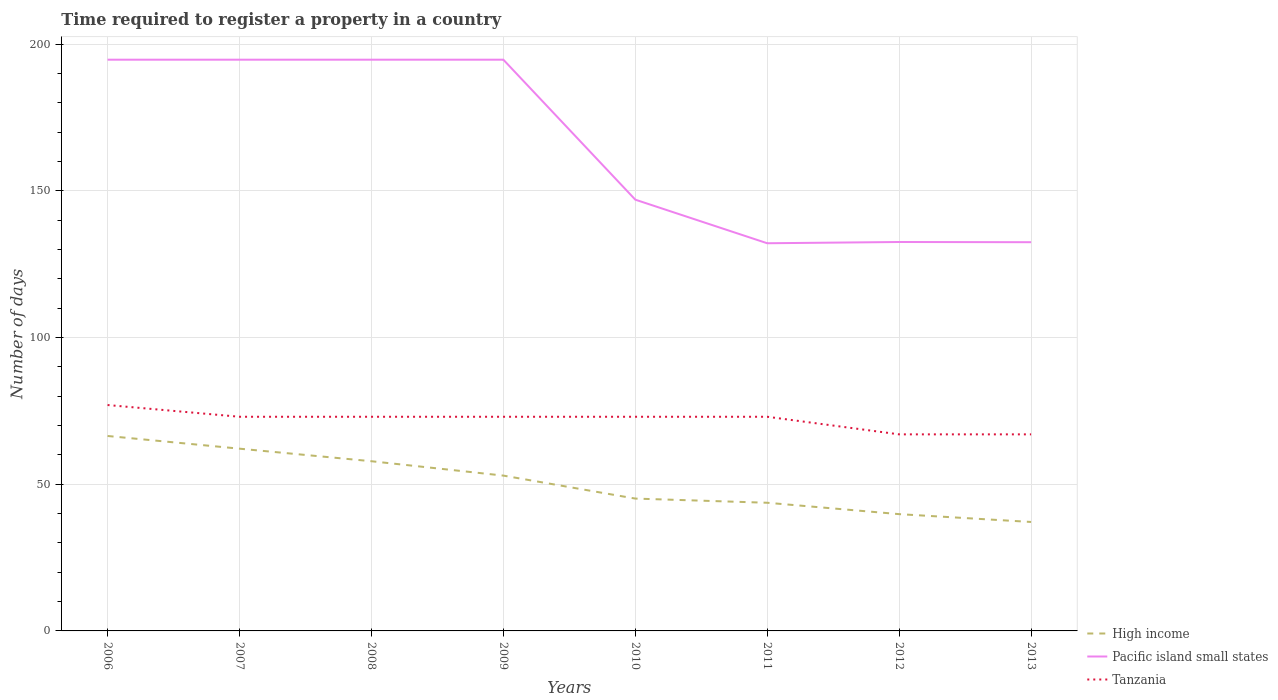How many different coloured lines are there?
Keep it short and to the point. 3. Does the line corresponding to Tanzania intersect with the line corresponding to Pacific island small states?
Your response must be concise. No. Is the number of lines equal to the number of legend labels?
Provide a short and direct response. Yes. Across all years, what is the maximum number of days required to register a property in Tanzania?
Offer a very short reply. 67. In which year was the number of days required to register a property in Pacific island small states maximum?
Give a very brief answer. 2011. What is the total number of days required to register a property in Tanzania in the graph?
Offer a terse response. 4. What is the difference between the highest and the second highest number of days required to register a property in Pacific island small states?
Provide a succinct answer. 62.57. Is the number of days required to register a property in Pacific island small states strictly greater than the number of days required to register a property in Tanzania over the years?
Provide a short and direct response. No. How many years are there in the graph?
Ensure brevity in your answer.  8. Are the values on the major ticks of Y-axis written in scientific E-notation?
Keep it short and to the point. No. Where does the legend appear in the graph?
Ensure brevity in your answer.  Bottom right. What is the title of the graph?
Your response must be concise. Time required to register a property in a country. Does "Antigua and Barbuda" appear as one of the legend labels in the graph?
Keep it short and to the point. No. What is the label or title of the X-axis?
Offer a terse response. Years. What is the label or title of the Y-axis?
Provide a succinct answer. Number of days. What is the Number of days in High income in 2006?
Your answer should be compact. 66.45. What is the Number of days of Pacific island small states in 2006?
Provide a succinct answer. 194.71. What is the Number of days in High income in 2007?
Offer a terse response. 62.12. What is the Number of days in Pacific island small states in 2007?
Your response must be concise. 194.71. What is the Number of days in High income in 2008?
Your response must be concise. 57.84. What is the Number of days in Pacific island small states in 2008?
Give a very brief answer. 194.71. What is the Number of days of Tanzania in 2008?
Make the answer very short. 73. What is the Number of days in High income in 2009?
Provide a succinct answer. 52.94. What is the Number of days of Pacific island small states in 2009?
Offer a terse response. 194.71. What is the Number of days in Tanzania in 2009?
Your answer should be very brief. 73. What is the Number of days of High income in 2010?
Your response must be concise. 45.11. What is the Number of days of Pacific island small states in 2010?
Make the answer very short. 147. What is the Number of days of Tanzania in 2010?
Provide a short and direct response. 73. What is the Number of days of High income in 2011?
Keep it short and to the point. 43.69. What is the Number of days in Pacific island small states in 2011?
Keep it short and to the point. 132.14. What is the Number of days of Tanzania in 2011?
Keep it short and to the point. 73. What is the Number of days in High income in 2012?
Your answer should be compact. 39.81. What is the Number of days in Pacific island small states in 2012?
Offer a terse response. 132.57. What is the Number of days in High income in 2013?
Your answer should be very brief. 37.14. What is the Number of days in Pacific island small states in 2013?
Give a very brief answer. 132.5. Across all years, what is the maximum Number of days of High income?
Provide a succinct answer. 66.45. Across all years, what is the maximum Number of days in Pacific island small states?
Provide a succinct answer. 194.71. Across all years, what is the minimum Number of days of High income?
Your response must be concise. 37.14. Across all years, what is the minimum Number of days of Pacific island small states?
Provide a succinct answer. 132.14. What is the total Number of days in High income in the graph?
Offer a terse response. 405.1. What is the total Number of days in Pacific island small states in the graph?
Ensure brevity in your answer.  1323.07. What is the total Number of days in Tanzania in the graph?
Your answer should be very brief. 576. What is the difference between the Number of days in High income in 2006 and that in 2007?
Provide a short and direct response. 4.33. What is the difference between the Number of days in Pacific island small states in 2006 and that in 2007?
Give a very brief answer. 0. What is the difference between the Number of days of High income in 2006 and that in 2008?
Your answer should be very brief. 8.61. What is the difference between the Number of days of Tanzania in 2006 and that in 2008?
Your answer should be compact. 4. What is the difference between the Number of days in High income in 2006 and that in 2009?
Ensure brevity in your answer.  13.51. What is the difference between the Number of days of Pacific island small states in 2006 and that in 2009?
Provide a short and direct response. 0. What is the difference between the Number of days of High income in 2006 and that in 2010?
Provide a short and direct response. 21.34. What is the difference between the Number of days in Pacific island small states in 2006 and that in 2010?
Offer a very short reply. 47.71. What is the difference between the Number of days in High income in 2006 and that in 2011?
Offer a very short reply. 22.76. What is the difference between the Number of days of Pacific island small states in 2006 and that in 2011?
Offer a very short reply. 62.57. What is the difference between the Number of days of High income in 2006 and that in 2012?
Keep it short and to the point. 26.64. What is the difference between the Number of days in Pacific island small states in 2006 and that in 2012?
Your answer should be very brief. 62.14. What is the difference between the Number of days in High income in 2006 and that in 2013?
Ensure brevity in your answer.  29.31. What is the difference between the Number of days of Pacific island small states in 2006 and that in 2013?
Offer a terse response. 62.21. What is the difference between the Number of days of Tanzania in 2006 and that in 2013?
Offer a very short reply. 10. What is the difference between the Number of days of High income in 2007 and that in 2008?
Your response must be concise. 4.28. What is the difference between the Number of days in Tanzania in 2007 and that in 2008?
Your answer should be very brief. 0. What is the difference between the Number of days in High income in 2007 and that in 2009?
Offer a very short reply. 9.18. What is the difference between the Number of days of Pacific island small states in 2007 and that in 2009?
Make the answer very short. 0. What is the difference between the Number of days of High income in 2007 and that in 2010?
Keep it short and to the point. 17.01. What is the difference between the Number of days of Pacific island small states in 2007 and that in 2010?
Offer a terse response. 47.71. What is the difference between the Number of days in High income in 2007 and that in 2011?
Your answer should be compact. 18.44. What is the difference between the Number of days in Pacific island small states in 2007 and that in 2011?
Provide a short and direct response. 62.57. What is the difference between the Number of days in High income in 2007 and that in 2012?
Your answer should be compact. 22.32. What is the difference between the Number of days in Pacific island small states in 2007 and that in 2012?
Provide a succinct answer. 62.14. What is the difference between the Number of days in High income in 2007 and that in 2013?
Keep it short and to the point. 24.99. What is the difference between the Number of days in Pacific island small states in 2007 and that in 2013?
Provide a succinct answer. 62.21. What is the difference between the Number of days in Tanzania in 2007 and that in 2013?
Give a very brief answer. 6. What is the difference between the Number of days of High income in 2008 and that in 2009?
Ensure brevity in your answer.  4.9. What is the difference between the Number of days in High income in 2008 and that in 2010?
Provide a short and direct response. 12.73. What is the difference between the Number of days of Pacific island small states in 2008 and that in 2010?
Provide a short and direct response. 47.71. What is the difference between the Number of days in High income in 2008 and that in 2011?
Give a very brief answer. 14.16. What is the difference between the Number of days in Pacific island small states in 2008 and that in 2011?
Provide a succinct answer. 62.57. What is the difference between the Number of days of High income in 2008 and that in 2012?
Provide a short and direct response. 18.04. What is the difference between the Number of days of Pacific island small states in 2008 and that in 2012?
Ensure brevity in your answer.  62.14. What is the difference between the Number of days in Tanzania in 2008 and that in 2012?
Your answer should be very brief. 6. What is the difference between the Number of days in High income in 2008 and that in 2013?
Your answer should be very brief. 20.71. What is the difference between the Number of days in Pacific island small states in 2008 and that in 2013?
Provide a short and direct response. 62.21. What is the difference between the Number of days in High income in 2009 and that in 2010?
Ensure brevity in your answer.  7.83. What is the difference between the Number of days of Pacific island small states in 2009 and that in 2010?
Ensure brevity in your answer.  47.71. What is the difference between the Number of days of High income in 2009 and that in 2011?
Offer a very short reply. 9.26. What is the difference between the Number of days of Pacific island small states in 2009 and that in 2011?
Make the answer very short. 62.57. What is the difference between the Number of days of Tanzania in 2009 and that in 2011?
Keep it short and to the point. 0. What is the difference between the Number of days in High income in 2009 and that in 2012?
Your answer should be compact. 13.14. What is the difference between the Number of days in Pacific island small states in 2009 and that in 2012?
Offer a very short reply. 62.14. What is the difference between the Number of days of Tanzania in 2009 and that in 2012?
Offer a very short reply. 6. What is the difference between the Number of days of High income in 2009 and that in 2013?
Offer a very short reply. 15.81. What is the difference between the Number of days in Pacific island small states in 2009 and that in 2013?
Offer a terse response. 62.21. What is the difference between the Number of days of Tanzania in 2009 and that in 2013?
Your response must be concise. 6. What is the difference between the Number of days in High income in 2010 and that in 2011?
Your answer should be very brief. 1.42. What is the difference between the Number of days in Pacific island small states in 2010 and that in 2011?
Ensure brevity in your answer.  14.86. What is the difference between the Number of days of Tanzania in 2010 and that in 2011?
Offer a very short reply. 0. What is the difference between the Number of days in High income in 2010 and that in 2012?
Offer a very short reply. 5.3. What is the difference between the Number of days of Pacific island small states in 2010 and that in 2012?
Keep it short and to the point. 14.43. What is the difference between the Number of days of High income in 2010 and that in 2013?
Offer a very short reply. 7.97. What is the difference between the Number of days of High income in 2011 and that in 2012?
Your answer should be very brief. 3.88. What is the difference between the Number of days in Pacific island small states in 2011 and that in 2012?
Keep it short and to the point. -0.43. What is the difference between the Number of days of Tanzania in 2011 and that in 2012?
Your answer should be compact. 6. What is the difference between the Number of days of High income in 2011 and that in 2013?
Keep it short and to the point. 6.55. What is the difference between the Number of days of Pacific island small states in 2011 and that in 2013?
Give a very brief answer. -0.36. What is the difference between the Number of days in High income in 2012 and that in 2013?
Give a very brief answer. 2.67. What is the difference between the Number of days in Pacific island small states in 2012 and that in 2013?
Keep it short and to the point. 0.07. What is the difference between the Number of days of Tanzania in 2012 and that in 2013?
Keep it short and to the point. 0. What is the difference between the Number of days of High income in 2006 and the Number of days of Pacific island small states in 2007?
Ensure brevity in your answer.  -128.26. What is the difference between the Number of days of High income in 2006 and the Number of days of Tanzania in 2007?
Ensure brevity in your answer.  -6.55. What is the difference between the Number of days of Pacific island small states in 2006 and the Number of days of Tanzania in 2007?
Make the answer very short. 121.71. What is the difference between the Number of days of High income in 2006 and the Number of days of Pacific island small states in 2008?
Offer a very short reply. -128.26. What is the difference between the Number of days of High income in 2006 and the Number of days of Tanzania in 2008?
Offer a very short reply. -6.55. What is the difference between the Number of days in Pacific island small states in 2006 and the Number of days in Tanzania in 2008?
Provide a succinct answer. 121.71. What is the difference between the Number of days in High income in 2006 and the Number of days in Pacific island small states in 2009?
Provide a short and direct response. -128.26. What is the difference between the Number of days of High income in 2006 and the Number of days of Tanzania in 2009?
Keep it short and to the point. -6.55. What is the difference between the Number of days of Pacific island small states in 2006 and the Number of days of Tanzania in 2009?
Provide a succinct answer. 121.71. What is the difference between the Number of days of High income in 2006 and the Number of days of Pacific island small states in 2010?
Your answer should be compact. -80.55. What is the difference between the Number of days of High income in 2006 and the Number of days of Tanzania in 2010?
Provide a succinct answer. -6.55. What is the difference between the Number of days in Pacific island small states in 2006 and the Number of days in Tanzania in 2010?
Your response must be concise. 121.71. What is the difference between the Number of days in High income in 2006 and the Number of days in Pacific island small states in 2011?
Provide a succinct answer. -65.69. What is the difference between the Number of days in High income in 2006 and the Number of days in Tanzania in 2011?
Ensure brevity in your answer.  -6.55. What is the difference between the Number of days of Pacific island small states in 2006 and the Number of days of Tanzania in 2011?
Ensure brevity in your answer.  121.71. What is the difference between the Number of days in High income in 2006 and the Number of days in Pacific island small states in 2012?
Make the answer very short. -66.12. What is the difference between the Number of days of High income in 2006 and the Number of days of Tanzania in 2012?
Your answer should be compact. -0.55. What is the difference between the Number of days of Pacific island small states in 2006 and the Number of days of Tanzania in 2012?
Your response must be concise. 127.71. What is the difference between the Number of days of High income in 2006 and the Number of days of Pacific island small states in 2013?
Offer a very short reply. -66.05. What is the difference between the Number of days of High income in 2006 and the Number of days of Tanzania in 2013?
Your answer should be very brief. -0.55. What is the difference between the Number of days in Pacific island small states in 2006 and the Number of days in Tanzania in 2013?
Offer a terse response. 127.71. What is the difference between the Number of days in High income in 2007 and the Number of days in Pacific island small states in 2008?
Keep it short and to the point. -132.59. What is the difference between the Number of days in High income in 2007 and the Number of days in Tanzania in 2008?
Ensure brevity in your answer.  -10.88. What is the difference between the Number of days of Pacific island small states in 2007 and the Number of days of Tanzania in 2008?
Offer a terse response. 121.71. What is the difference between the Number of days in High income in 2007 and the Number of days in Pacific island small states in 2009?
Provide a succinct answer. -132.59. What is the difference between the Number of days in High income in 2007 and the Number of days in Tanzania in 2009?
Offer a very short reply. -10.88. What is the difference between the Number of days in Pacific island small states in 2007 and the Number of days in Tanzania in 2009?
Offer a very short reply. 121.71. What is the difference between the Number of days of High income in 2007 and the Number of days of Pacific island small states in 2010?
Your answer should be compact. -84.88. What is the difference between the Number of days in High income in 2007 and the Number of days in Tanzania in 2010?
Provide a succinct answer. -10.88. What is the difference between the Number of days in Pacific island small states in 2007 and the Number of days in Tanzania in 2010?
Provide a short and direct response. 121.71. What is the difference between the Number of days of High income in 2007 and the Number of days of Pacific island small states in 2011?
Make the answer very short. -70.02. What is the difference between the Number of days in High income in 2007 and the Number of days in Tanzania in 2011?
Keep it short and to the point. -10.88. What is the difference between the Number of days in Pacific island small states in 2007 and the Number of days in Tanzania in 2011?
Your answer should be compact. 121.71. What is the difference between the Number of days in High income in 2007 and the Number of days in Pacific island small states in 2012?
Keep it short and to the point. -70.45. What is the difference between the Number of days of High income in 2007 and the Number of days of Tanzania in 2012?
Provide a succinct answer. -4.88. What is the difference between the Number of days in Pacific island small states in 2007 and the Number of days in Tanzania in 2012?
Provide a succinct answer. 127.71. What is the difference between the Number of days in High income in 2007 and the Number of days in Pacific island small states in 2013?
Offer a terse response. -70.38. What is the difference between the Number of days of High income in 2007 and the Number of days of Tanzania in 2013?
Provide a short and direct response. -4.88. What is the difference between the Number of days of Pacific island small states in 2007 and the Number of days of Tanzania in 2013?
Offer a very short reply. 127.71. What is the difference between the Number of days in High income in 2008 and the Number of days in Pacific island small states in 2009?
Make the answer very short. -136.87. What is the difference between the Number of days of High income in 2008 and the Number of days of Tanzania in 2009?
Make the answer very short. -15.16. What is the difference between the Number of days of Pacific island small states in 2008 and the Number of days of Tanzania in 2009?
Keep it short and to the point. 121.71. What is the difference between the Number of days of High income in 2008 and the Number of days of Pacific island small states in 2010?
Your answer should be very brief. -89.16. What is the difference between the Number of days of High income in 2008 and the Number of days of Tanzania in 2010?
Your answer should be very brief. -15.16. What is the difference between the Number of days in Pacific island small states in 2008 and the Number of days in Tanzania in 2010?
Your response must be concise. 121.71. What is the difference between the Number of days of High income in 2008 and the Number of days of Pacific island small states in 2011?
Provide a short and direct response. -74.3. What is the difference between the Number of days of High income in 2008 and the Number of days of Tanzania in 2011?
Keep it short and to the point. -15.16. What is the difference between the Number of days in Pacific island small states in 2008 and the Number of days in Tanzania in 2011?
Provide a succinct answer. 121.71. What is the difference between the Number of days of High income in 2008 and the Number of days of Pacific island small states in 2012?
Ensure brevity in your answer.  -74.73. What is the difference between the Number of days in High income in 2008 and the Number of days in Tanzania in 2012?
Ensure brevity in your answer.  -9.16. What is the difference between the Number of days of Pacific island small states in 2008 and the Number of days of Tanzania in 2012?
Offer a terse response. 127.71. What is the difference between the Number of days in High income in 2008 and the Number of days in Pacific island small states in 2013?
Offer a terse response. -74.66. What is the difference between the Number of days of High income in 2008 and the Number of days of Tanzania in 2013?
Offer a terse response. -9.16. What is the difference between the Number of days of Pacific island small states in 2008 and the Number of days of Tanzania in 2013?
Your answer should be very brief. 127.71. What is the difference between the Number of days in High income in 2009 and the Number of days in Pacific island small states in 2010?
Offer a very short reply. -94.06. What is the difference between the Number of days of High income in 2009 and the Number of days of Tanzania in 2010?
Offer a terse response. -20.06. What is the difference between the Number of days of Pacific island small states in 2009 and the Number of days of Tanzania in 2010?
Provide a short and direct response. 121.71. What is the difference between the Number of days of High income in 2009 and the Number of days of Pacific island small states in 2011?
Your answer should be compact. -79.2. What is the difference between the Number of days in High income in 2009 and the Number of days in Tanzania in 2011?
Your response must be concise. -20.06. What is the difference between the Number of days of Pacific island small states in 2009 and the Number of days of Tanzania in 2011?
Keep it short and to the point. 121.71. What is the difference between the Number of days in High income in 2009 and the Number of days in Pacific island small states in 2012?
Your answer should be compact. -79.63. What is the difference between the Number of days in High income in 2009 and the Number of days in Tanzania in 2012?
Your answer should be very brief. -14.06. What is the difference between the Number of days of Pacific island small states in 2009 and the Number of days of Tanzania in 2012?
Provide a succinct answer. 127.71. What is the difference between the Number of days of High income in 2009 and the Number of days of Pacific island small states in 2013?
Keep it short and to the point. -79.56. What is the difference between the Number of days in High income in 2009 and the Number of days in Tanzania in 2013?
Give a very brief answer. -14.06. What is the difference between the Number of days in Pacific island small states in 2009 and the Number of days in Tanzania in 2013?
Your answer should be very brief. 127.71. What is the difference between the Number of days in High income in 2010 and the Number of days in Pacific island small states in 2011?
Offer a very short reply. -87.03. What is the difference between the Number of days of High income in 2010 and the Number of days of Tanzania in 2011?
Make the answer very short. -27.89. What is the difference between the Number of days in High income in 2010 and the Number of days in Pacific island small states in 2012?
Provide a succinct answer. -87.46. What is the difference between the Number of days in High income in 2010 and the Number of days in Tanzania in 2012?
Keep it short and to the point. -21.89. What is the difference between the Number of days of High income in 2010 and the Number of days of Pacific island small states in 2013?
Make the answer very short. -87.39. What is the difference between the Number of days of High income in 2010 and the Number of days of Tanzania in 2013?
Your answer should be compact. -21.89. What is the difference between the Number of days of Pacific island small states in 2010 and the Number of days of Tanzania in 2013?
Offer a very short reply. 80. What is the difference between the Number of days of High income in 2011 and the Number of days of Pacific island small states in 2012?
Offer a terse response. -88.88. What is the difference between the Number of days in High income in 2011 and the Number of days in Tanzania in 2012?
Keep it short and to the point. -23.31. What is the difference between the Number of days in Pacific island small states in 2011 and the Number of days in Tanzania in 2012?
Your answer should be very brief. 65.14. What is the difference between the Number of days of High income in 2011 and the Number of days of Pacific island small states in 2013?
Ensure brevity in your answer.  -88.81. What is the difference between the Number of days in High income in 2011 and the Number of days in Tanzania in 2013?
Give a very brief answer. -23.31. What is the difference between the Number of days of Pacific island small states in 2011 and the Number of days of Tanzania in 2013?
Your response must be concise. 65.14. What is the difference between the Number of days of High income in 2012 and the Number of days of Pacific island small states in 2013?
Provide a succinct answer. -92.69. What is the difference between the Number of days of High income in 2012 and the Number of days of Tanzania in 2013?
Make the answer very short. -27.19. What is the difference between the Number of days of Pacific island small states in 2012 and the Number of days of Tanzania in 2013?
Your answer should be very brief. 65.57. What is the average Number of days of High income per year?
Your response must be concise. 50.64. What is the average Number of days of Pacific island small states per year?
Offer a very short reply. 165.38. In the year 2006, what is the difference between the Number of days of High income and Number of days of Pacific island small states?
Keep it short and to the point. -128.26. In the year 2006, what is the difference between the Number of days in High income and Number of days in Tanzania?
Offer a terse response. -10.55. In the year 2006, what is the difference between the Number of days in Pacific island small states and Number of days in Tanzania?
Your answer should be compact. 117.71. In the year 2007, what is the difference between the Number of days of High income and Number of days of Pacific island small states?
Keep it short and to the point. -132.59. In the year 2007, what is the difference between the Number of days in High income and Number of days in Tanzania?
Your answer should be compact. -10.88. In the year 2007, what is the difference between the Number of days in Pacific island small states and Number of days in Tanzania?
Offer a very short reply. 121.71. In the year 2008, what is the difference between the Number of days of High income and Number of days of Pacific island small states?
Offer a terse response. -136.87. In the year 2008, what is the difference between the Number of days in High income and Number of days in Tanzania?
Keep it short and to the point. -15.16. In the year 2008, what is the difference between the Number of days of Pacific island small states and Number of days of Tanzania?
Keep it short and to the point. 121.71. In the year 2009, what is the difference between the Number of days in High income and Number of days in Pacific island small states?
Ensure brevity in your answer.  -141.77. In the year 2009, what is the difference between the Number of days of High income and Number of days of Tanzania?
Your response must be concise. -20.06. In the year 2009, what is the difference between the Number of days of Pacific island small states and Number of days of Tanzania?
Ensure brevity in your answer.  121.71. In the year 2010, what is the difference between the Number of days in High income and Number of days in Pacific island small states?
Keep it short and to the point. -101.89. In the year 2010, what is the difference between the Number of days of High income and Number of days of Tanzania?
Provide a short and direct response. -27.89. In the year 2011, what is the difference between the Number of days in High income and Number of days in Pacific island small states?
Provide a succinct answer. -88.46. In the year 2011, what is the difference between the Number of days of High income and Number of days of Tanzania?
Offer a very short reply. -29.31. In the year 2011, what is the difference between the Number of days of Pacific island small states and Number of days of Tanzania?
Keep it short and to the point. 59.14. In the year 2012, what is the difference between the Number of days of High income and Number of days of Pacific island small states?
Provide a short and direct response. -92.76. In the year 2012, what is the difference between the Number of days of High income and Number of days of Tanzania?
Provide a short and direct response. -27.19. In the year 2012, what is the difference between the Number of days of Pacific island small states and Number of days of Tanzania?
Offer a terse response. 65.57. In the year 2013, what is the difference between the Number of days of High income and Number of days of Pacific island small states?
Offer a very short reply. -95.36. In the year 2013, what is the difference between the Number of days in High income and Number of days in Tanzania?
Provide a succinct answer. -29.86. In the year 2013, what is the difference between the Number of days in Pacific island small states and Number of days in Tanzania?
Your answer should be very brief. 65.5. What is the ratio of the Number of days in High income in 2006 to that in 2007?
Give a very brief answer. 1.07. What is the ratio of the Number of days of Pacific island small states in 2006 to that in 2007?
Offer a very short reply. 1. What is the ratio of the Number of days in Tanzania in 2006 to that in 2007?
Keep it short and to the point. 1.05. What is the ratio of the Number of days of High income in 2006 to that in 2008?
Give a very brief answer. 1.15. What is the ratio of the Number of days in Pacific island small states in 2006 to that in 2008?
Offer a very short reply. 1. What is the ratio of the Number of days of Tanzania in 2006 to that in 2008?
Keep it short and to the point. 1.05. What is the ratio of the Number of days of High income in 2006 to that in 2009?
Your answer should be compact. 1.26. What is the ratio of the Number of days in Tanzania in 2006 to that in 2009?
Offer a very short reply. 1.05. What is the ratio of the Number of days in High income in 2006 to that in 2010?
Provide a succinct answer. 1.47. What is the ratio of the Number of days of Pacific island small states in 2006 to that in 2010?
Provide a short and direct response. 1.32. What is the ratio of the Number of days in Tanzania in 2006 to that in 2010?
Your answer should be compact. 1.05. What is the ratio of the Number of days in High income in 2006 to that in 2011?
Your response must be concise. 1.52. What is the ratio of the Number of days in Pacific island small states in 2006 to that in 2011?
Keep it short and to the point. 1.47. What is the ratio of the Number of days in Tanzania in 2006 to that in 2011?
Give a very brief answer. 1.05. What is the ratio of the Number of days in High income in 2006 to that in 2012?
Offer a very short reply. 1.67. What is the ratio of the Number of days of Pacific island small states in 2006 to that in 2012?
Provide a short and direct response. 1.47. What is the ratio of the Number of days of Tanzania in 2006 to that in 2012?
Provide a short and direct response. 1.15. What is the ratio of the Number of days in High income in 2006 to that in 2013?
Keep it short and to the point. 1.79. What is the ratio of the Number of days in Pacific island small states in 2006 to that in 2013?
Your response must be concise. 1.47. What is the ratio of the Number of days in Tanzania in 2006 to that in 2013?
Offer a very short reply. 1.15. What is the ratio of the Number of days in High income in 2007 to that in 2008?
Your response must be concise. 1.07. What is the ratio of the Number of days of Tanzania in 2007 to that in 2008?
Your response must be concise. 1. What is the ratio of the Number of days of High income in 2007 to that in 2009?
Make the answer very short. 1.17. What is the ratio of the Number of days of Tanzania in 2007 to that in 2009?
Ensure brevity in your answer.  1. What is the ratio of the Number of days in High income in 2007 to that in 2010?
Your answer should be very brief. 1.38. What is the ratio of the Number of days of Pacific island small states in 2007 to that in 2010?
Give a very brief answer. 1.32. What is the ratio of the Number of days in Tanzania in 2007 to that in 2010?
Your answer should be compact. 1. What is the ratio of the Number of days of High income in 2007 to that in 2011?
Your answer should be compact. 1.42. What is the ratio of the Number of days of Pacific island small states in 2007 to that in 2011?
Your answer should be compact. 1.47. What is the ratio of the Number of days of Tanzania in 2007 to that in 2011?
Your answer should be very brief. 1. What is the ratio of the Number of days in High income in 2007 to that in 2012?
Offer a very short reply. 1.56. What is the ratio of the Number of days of Pacific island small states in 2007 to that in 2012?
Provide a succinct answer. 1.47. What is the ratio of the Number of days of Tanzania in 2007 to that in 2012?
Your answer should be very brief. 1.09. What is the ratio of the Number of days of High income in 2007 to that in 2013?
Provide a succinct answer. 1.67. What is the ratio of the Number of days of Pacific island small states in 2007 to that in 2013?
Keep it short and to the point. 1.47. What is the ratio of the Number of days of Tanzania in 2007 to that in 2013?
Make the answer very short. 1.09. What is the ratio of the Number of days in High income in 2008 to that in 2009?
Your answer should be very brief. 1.09. What is the ratio of the Number of days of Pacific island small states in 2008 to that in 2009?
Make the answer very short. 1. What is the ratio of the Number of days in Tanzania in 2008 to that in 2009?
Keep it short and to the point. 1. What is the ratio of the Number of days of High income in 2008 to that in 2010?
Your answer should be very brief. 1.28. What is the ratio of the Number of days of Pacific island small states in 2008 to that in 2010?
Your answer should be compact. 1.32. What is the ratio of the Number of days in Tanzania in 2008 to that in 2010?
Give a very brief answer. 1. What is the ratio of the Number of days of High income in 2008 to that in 2011?
Offer a terse response. 1.32. What is the ratio of the Number of days of Pacific island small states in 2008 to that in 2011?
Make the answer very short. 1.47. What is the ratio of the Number of days in Tanzania in 2008 to that in 2011?
Offer a terse response. 1. What is the ratio of the Number of days of High income in 2008 to that in 2012?
Provide a short and direct response. 1.45. What is the ratio of the Number of days of Pacific island small states in 2008 to that in 2012?
Your response must be concise. 1.47. What is the ratio of the Number of days of Tanzania in 2008 to that in 2012?
Your answer should be compact. 1.09. What is the ratio of the Number of days in High income in 2008 to that in 2013?
Ensure brevity in your answer.  1.56. What is the ratio of the Number of days in Pacific island small states in 2008 to that in 2013?
Ensure brevity in your answer.  1.47. What is the ratio of the Number of days of Tanzania in 2008 to that in 2013?
Provide a short and direct response. 1.09. What is the ratio of the Number of days in High income in 2009 to that in 2010?
Provide a short and direct response. 1.17. What is the ratio of the Number of days in Pacific island small states in 2009 to that in 2010?
Keep it short and to the point. 1.32. What is the ratio of the Number of days in High income in 2009 to that in 2011?
Provide a succinct answer. 1.21. What is the ratio of the Number of days in Pacific island small states in 2009 to that in 2011?
Provide a succinct answer. 1.47. What is the ratio of the Number of days of High income in 2009 to that in 2012?
Offer a very short reply. 1.33. What is the ratio of the Number of days of Pacific island small states in 2009 to that in 2012?
Provide a short and direct response. 1.47. What is the ratio of the Number of days of Tanzania in 2009 to that in 2012?
Provide a succinct answer. 1.09. What is the ratio of the Number of days of High income in 2009 to that in 2013?
Make the answer very short. 1.43. What is the ratio of the Number of days of Pacific island small states in 2009 to that in 2013?
Offer a very short reply. 1.47. What is the ratio of the Number of days of Tanzania in 2009 to that in 2013?
Keep it short and to the point. 1.09. What is the ratio of the Number of days in High income in 2010 to that in 2011?
Make the answer very short. 1.03. What is the ratio of the Number of days in Pacific island small states in 2010 to that in 2011?
Provide a short and direct response. 1.11. What is the ratio of the Number of days of High income in 2010 to that in 2012?
Your answer should be compact. 1.13. What is the ratio of the Number of days in Pacific island small states in 2010 to that in 2012?
Ensure brevity in your answer.  1.11. What is the ratio of the Number of days in Tanzania in 2010 to that in 2012?
Your answer should be very brief. 1.09. What is the ratio of the Number of days of High income in 2010 to that in 2013?
Ensure brevity in your answer.  1.21. What is the ratio of the Number of days of Pacific island small states in 2010 to that in 2013?
Give a very brief answer. 1.11. What is the ratio of the Number of days of Tanzania in 2010 to that in 2013?
Your answer should be very brief. 1.09. What is the ratio of the Number of days in High income in 2011 to that in 2012?
Keep it short and to the point. 1.1. What is the ratio of the Number of days in Pacific island small states in 2011 to that in 2012?
Offer a very short reply. 1. What is the ratio of the Number of days of Tanzania in 2011 to that in 2012?
Ensure brevity in your answer.  1.09. What is the ratio of the Number of days in High income in 2011 to that in 2013?
Your answer should be very brief. 1.18. What is the ratio of the Number of days of Tanzania in 2011 to that in 2013?
Keep it short and to the point. 1.09. What is the ratio of the Number of days in High income in 2012 to that in 2013?
Provide a succinct answer. 1.07. What is the difference between the highest and the second highest Number of days in High income?
Provide a succinct answer. 4.33. What is the difference between the highest and the second highest Number of days of Tanzania?
Make the answer very short. 4. What is the difference between the highest and the lowest Number of days of High income?
Offer a terse response. 29.31. What is the difference between the highest and the lowest Number of days in Pacific island small states?
Offer a terse response. 62.57. 